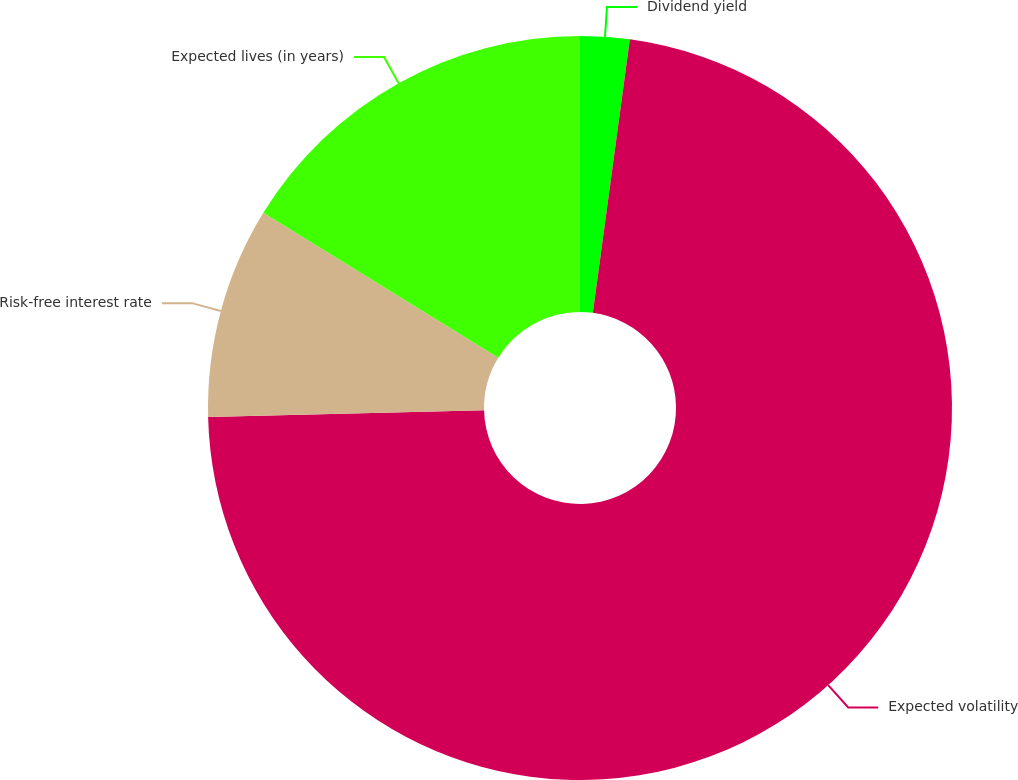Convert chart to OTSL. <chart><loc_0><loc_0><loc_500><loc_500><pie_chart><fcel>Dividend yield<fcel>Expected volatility<fcel>Risk-free interest rate<fcel>Expected lives (in years)<nl><fcel>2.14%<fcel>72.47%<fcel>9.18%<fcel>16.21%<nl></chart> 